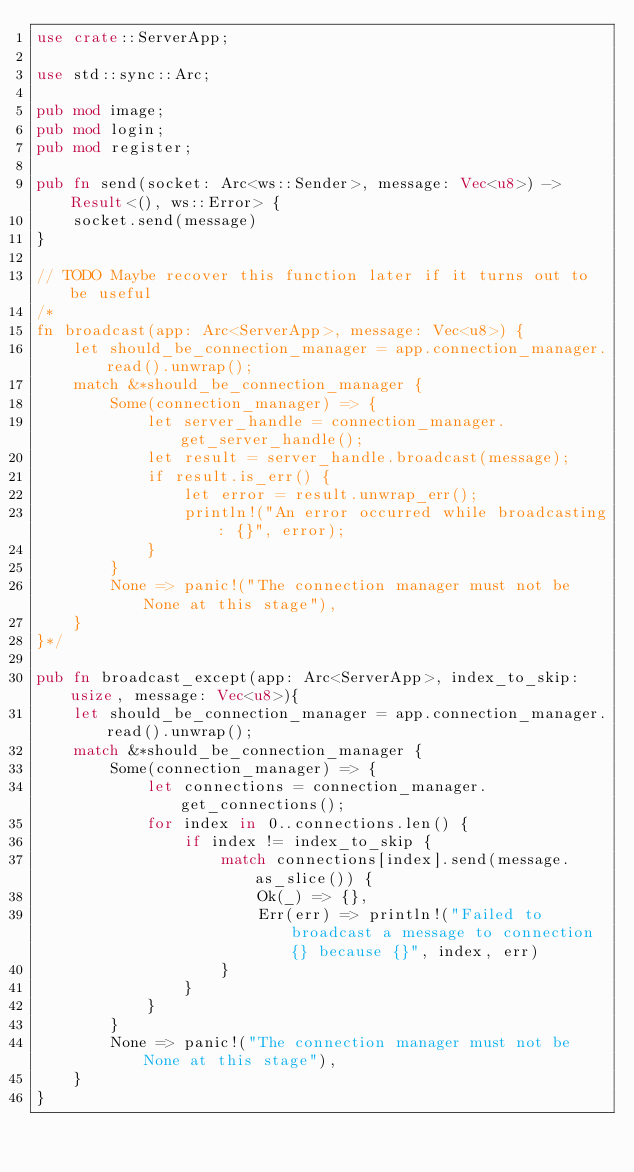Convert code to text. <code><loc_0><loc_0><loc_500><loc_500><_Rust_>use crate::ServerApp;

use std::sync::Arc;

pub mod image;
pub mod login;
pub mod register;

pub fn send(socket: Arc<ws::Sender>, message: Vec<u8>) -> Result<(), ws::Error> {
    socket.send(message)
}

// TODO Maybe recover this function later if it turns out to be useful
/*
fn broadcast(app: Arc<ServerApp>, message: Vec<u8>) {
    let should_be_connection_manager = app.connection_manager.read().unwrap();
    match &*should_be_connection_manager {
        Some(connection_manager) => {
            let server_handle = connection_manager.get_server_handle();
            let result = server_handle.broadcast(message);
            if result.is_err() {
                let error = result.unwrap_err();
                println!("An error occurred while broadcasting: {}", error);
            }
        }
        None => panic!("The connection manager must not be None at this stage"),
    }
}*/

pub fn broadcast_except(app: Arc<ServerApp>, index_to_skip: usize, message: Vec<u8>){
    let should_be_connection_manager = app.connection_manager.read().unwrap();
    match &*should_be_connection_manager {
        Some(connection_manager) => {
            let connections = connection_manager.get_connections();
            for index in 0..connections.len() {
                if index != index_to_skip {
                    match connections[index].send(message.as_slice()) {
                        Ok(_) => {},
                        Err(err) => println!("Failed to broadcast a message to connection {} because {}", index, err)
                    }
                }
            }
        }
        None => panic!("The connection manager must not be None at this stage"),
    }
}</code> 